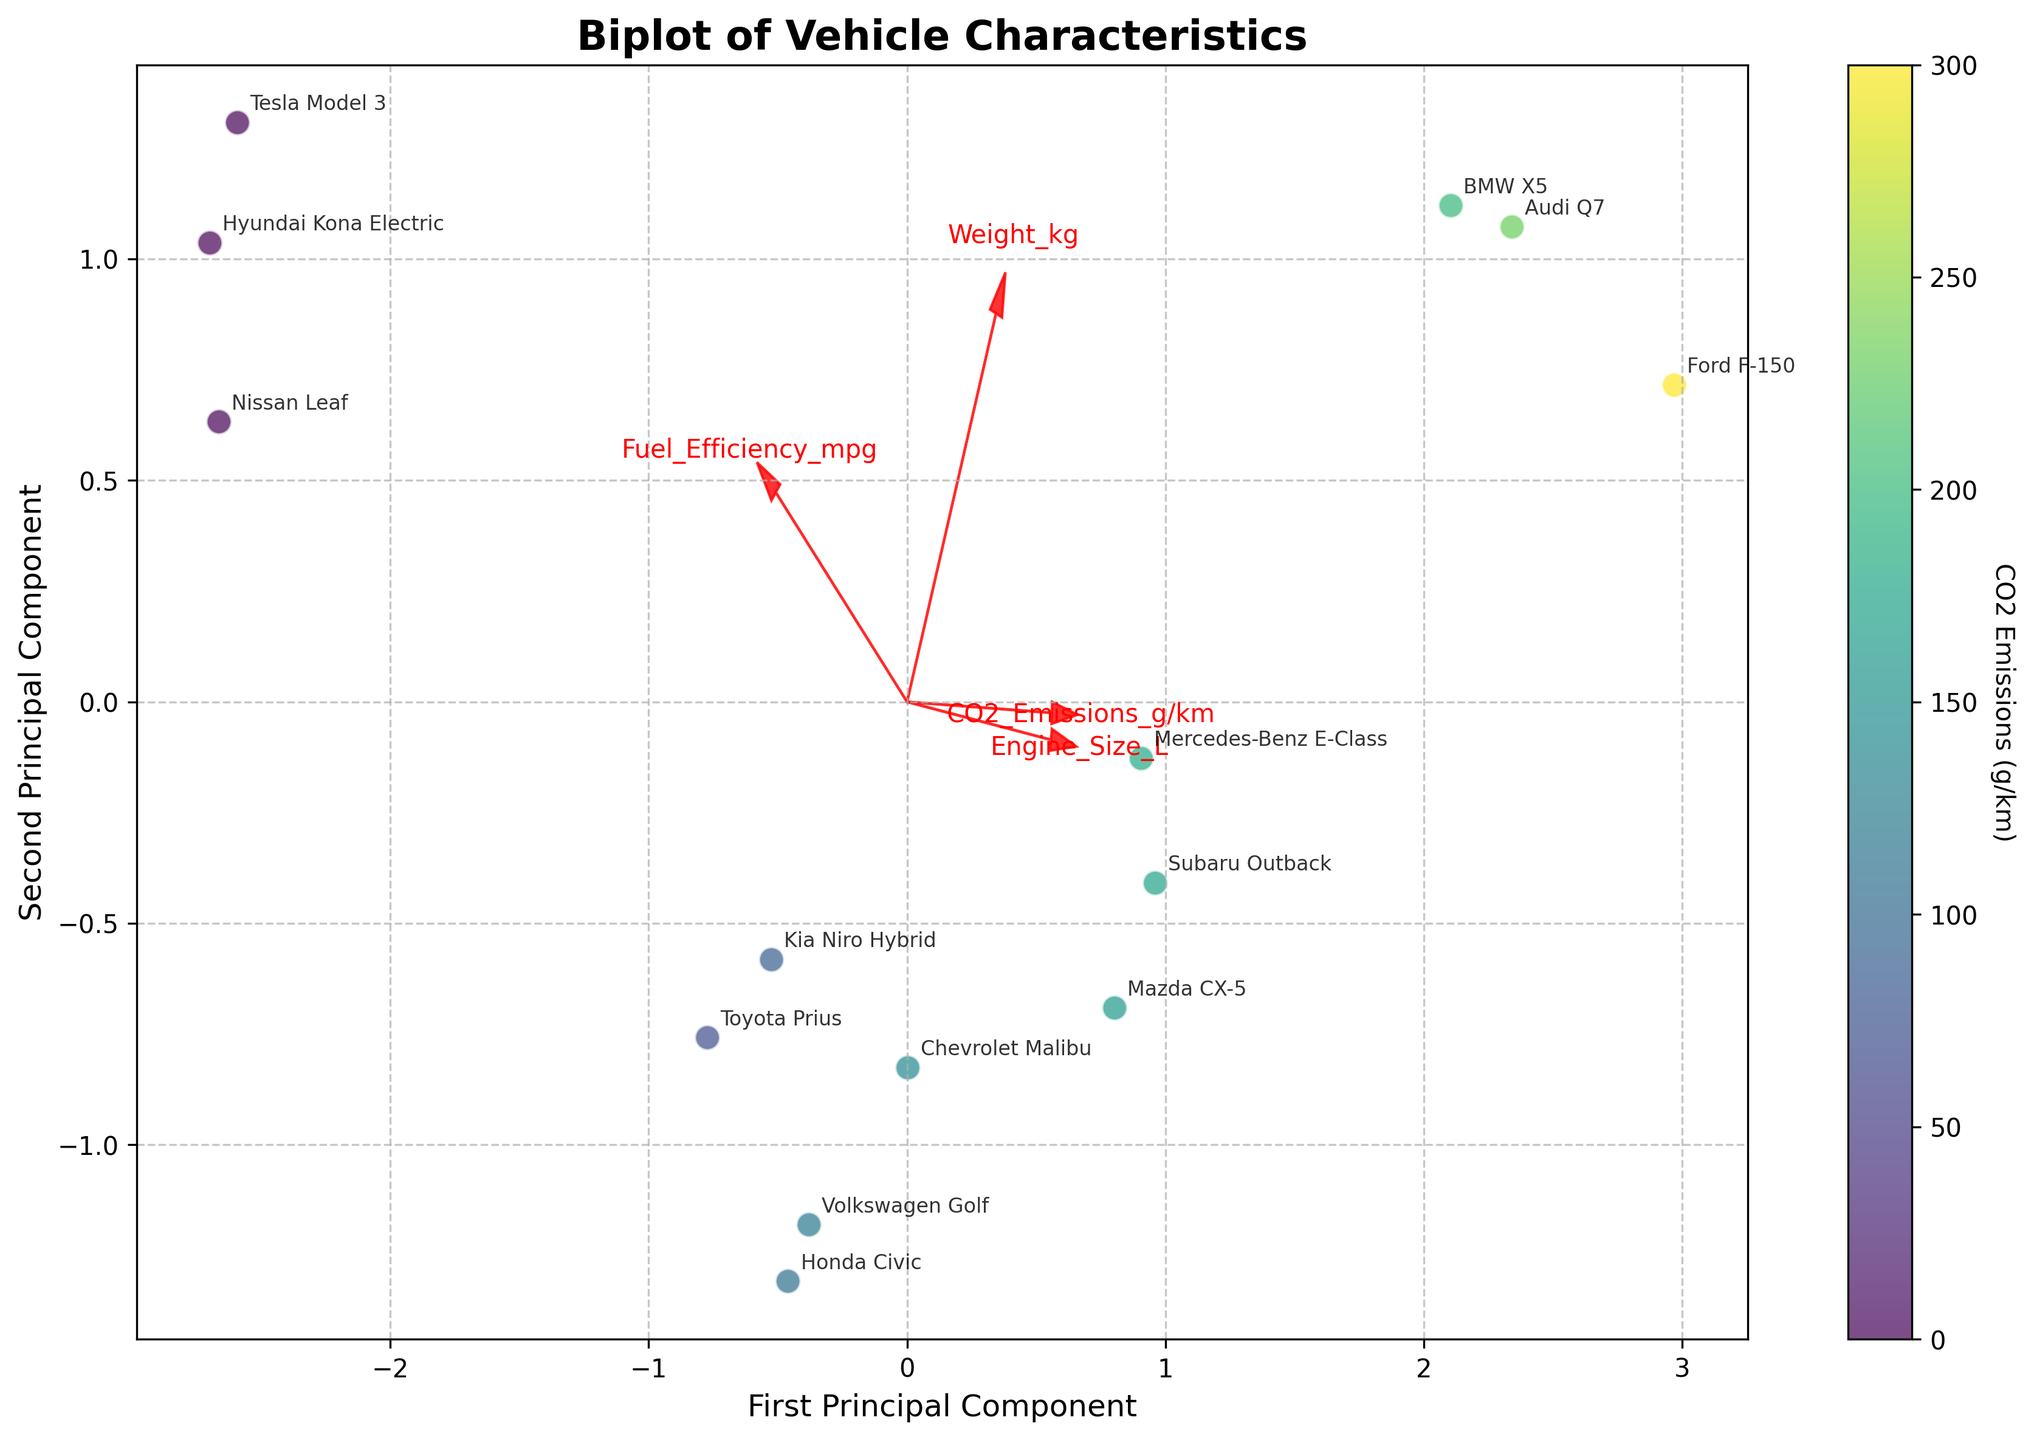what is the title of the plot? The title is located at the top of the plot and typically in a larger or bold font to make it easily visible. It helps to understand what the plot is about.
Answer: Biplot of Vehicle Characteristics How many principal components are shown in the plot? The axes labels "First Principal Component" and "Second Principal Component" indicate the number of principal components being shown.
Answer: 2 Which car model has the highest CO2 Emissions as per the color scale? The color scale (colorbar) indicates CO2 emissions. By locating the point with the darkest color, we identify the car with the highest CO2 emissions.
Answer: Ford F-150 Which variable has the longest arrow, indicating the highest contribution to the principal components? By inspecting the lengths of the arrows representing each feature, the feature with the longest arrow has the highest contribution.
Answer: CO2 Emissions Which vehicle is positioned closest to the origin of the plot? The vehicle closest to the origin (0,0) of the plot can be identified by inspecting the data points' positions relative to the center.
Answer: Mazda CX-5 What is the relationship between CO2 emissions and fuel efficiency based on the biplot arrows? By examining the direction of the arrows for CO2 emissions and fuel efficiency, one can determine if they are pointing in the same or opposite directions, indicating a positive or negative relationship.
Answer: Negative relationship Which two car models are the most similar based on their principal component scores? The similarity between car models can be inferred from the proximity of data points on the plot.
Answer: Hyundai Kona Electric and Tesla Model 3 What can you infer about the engine size's impact on vehicle characteristics based on its arrow direction? By observing the arrow direction for "Engine_Size_L," we can infer which principal component it mainly contributes to and its relationship with other variables.
Answer: Larger engine size correlates with higher CO2 emissions and lower fuel efficiency Which feature has the least contribution to the second principal component? By inspecting the position of each feature's arrow, the feature closest to the horizontal axis of the second principal component represents the least contribution.
Answer: Weight_kg How do electric cars stand out in the plot concerning CO2 emissions and fuel efficiency? By identifying electric cars (e.g., Tesla Model 3, Nissan Leaf, Hyundai Kona Electric) and comparing their positions and color intensity with other vehicles, we can interpret their emissions and efficiency characteristics.
Answer: Electric cars have zero CO2 emissions and high fuel efficiency 